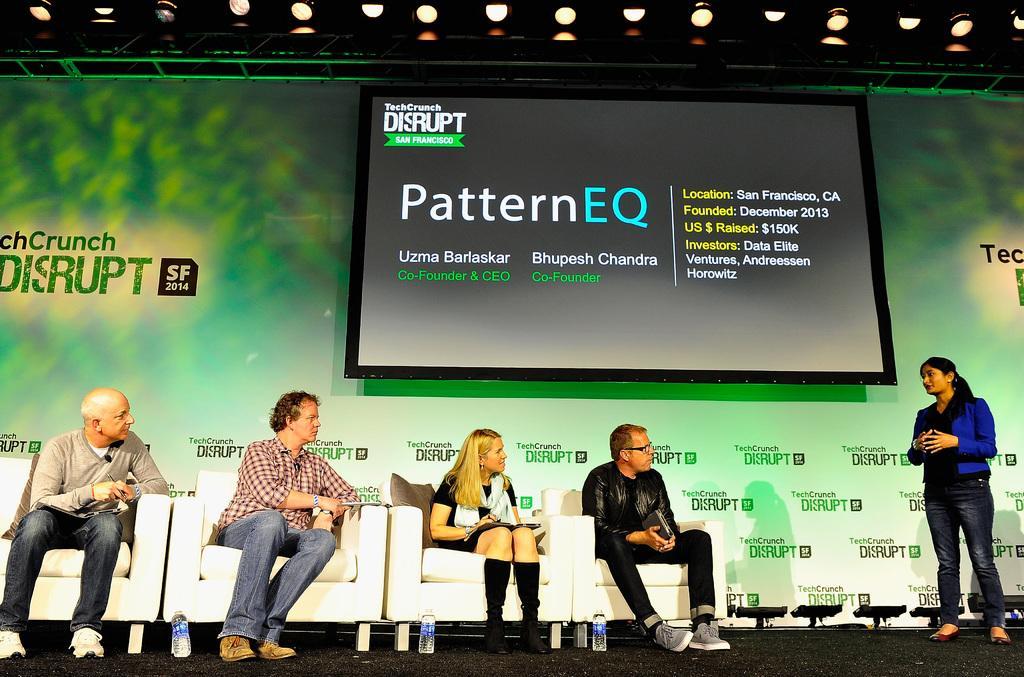Can you describe this image briefly? In the center of the image we can see four persons are sitting on a couch. On the right side of the image a lady is standing. In the background of the image we can see screen, board, lights are there. At the bottom of the image we can see bottles, floor are there. 